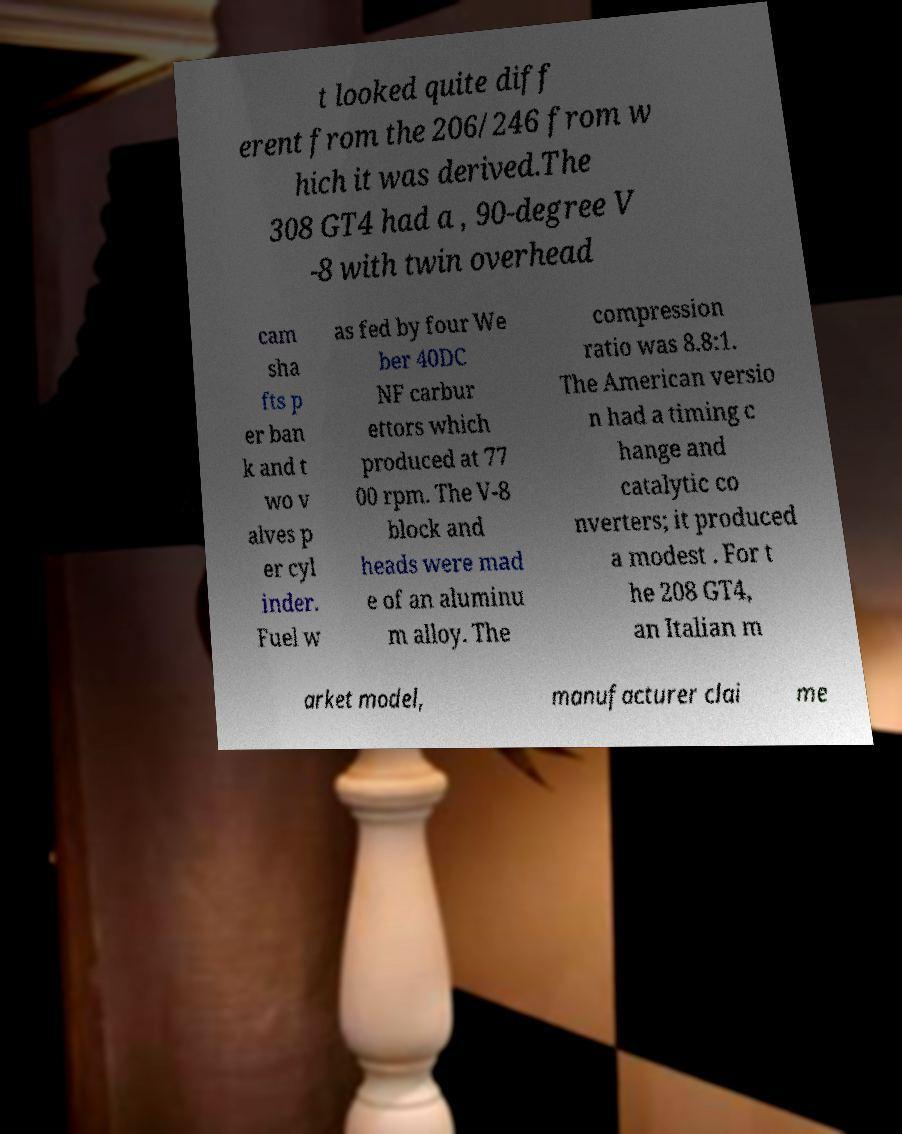Please read and relay the text visible in this image. What does it say? t looked quite diff erent from the 206/246 from w hich it was derived.The 308 GT4 had a , 90-degree V -8 with twin overhead cam sha fts p er ban k and t wo v alves p er cyl inder. Fuel w as fed by four We ber 40DC NF carbur ettors which produced at 77 00 rpm. The V-8 block and heads were mad e of an aluminu m alloy. The compression ratio was 8.8:1. The American versio n had a timing c hange and catalytic co nverters; it produced a modest . For t he 208 GT4, an Italian m arket model, manufacturer clai me 